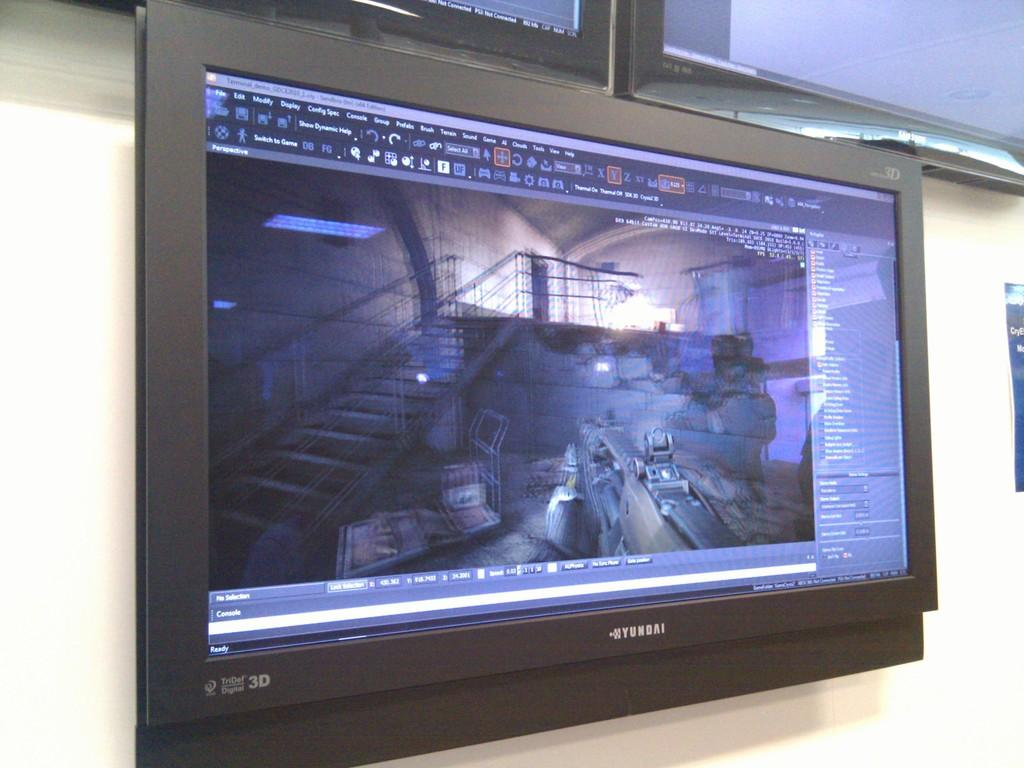What electronic device is present in the image? There is a television in the image. What color is the wall behind the television? The wall is white in the image. What type of joke is being told on the television in the image? There is no information about a joke being told on the television in the image. 